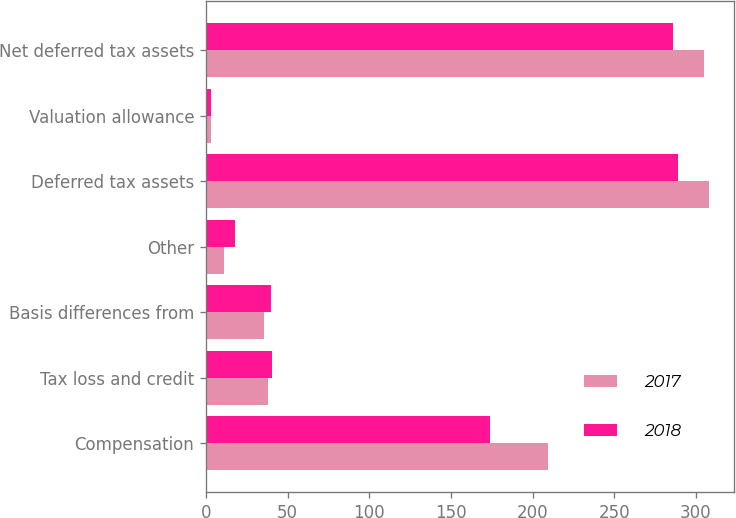Convert chart. <chart><loc_0><loc_0><loc_500><loc_500><stacked_bar_chart><ecel><fcel>Compensation<fcel>Tax loss and credit<fcel>Basis differences from<fcel>Other<fcel>Deferred tax assets<fcel>Valuation allowance<fcel>Net deferred tax assets<nl><fcel>2017<fcel>209.7<fcel>38.1<fcel>35.7<fcel>10.8<fcel>308.2<fcel>3<fcel>305.2<nl><fcel>2018<fcel>173.7<fcel>40.3<fcel>39.5<fcel>17.8<fcel>289.3<fcel>3.3<fcel>286<nl></chart> 